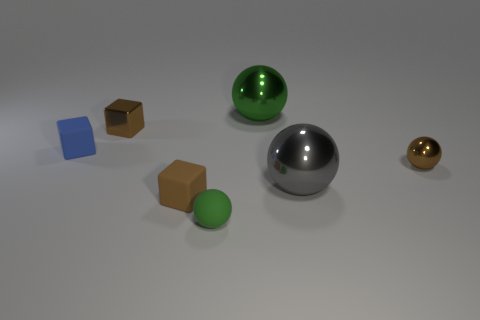There is a brown cube that is the same material as the blue object; what is its size?
Provide a succinct answer. Small. The metallic thing that is the same color as the metallic block is what size?
Keep it short and to the point. Small. Is the size of the brown block in front of the brown ball the same as the big gray object?
Your response must be concise. No. Do the blue object and the big gray ball have the same material?
Make the answer very short. No. There is a tiny metallic thing that is to the right of the big shiny ball behind the tiny brown shiny thing right of the small green rubber ball; what shape is it?
Provide a succinct answer. Sphere. What is the block that is both in front of the brown metal block and on the left side of the brown matte cube made of?
Your answer should be compact. Rubber. There is a small metallic thing right of the rubber block that is in front of the brown metal thing on the right side of the big gray ball; what color is it?
Your response must be concise. Brown. What number of brown things are rubber spheres or tiny metallic cubes?
Your answer should be compact. 1. How many other objects are the same size as the blue matte object?
Your answer should be very brief. 4. What number of large gray things are there?
Give a very brief answer. 1. 